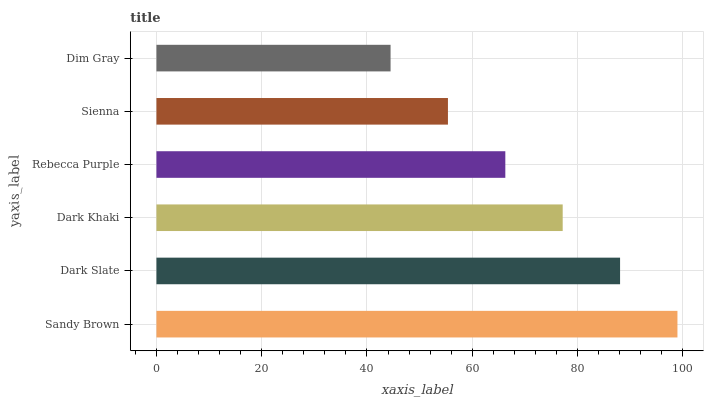Is Dim Gray the minimum?
Answer yes or no. Yes. Is Sandy Brown the maximum?
Answer yes or no. Yes. Is Dark Slate the minimum?
Answer yes or no. No. Is Dark Slate the maximum?
Answer yes or no. No. Is Sandy Brown greater than Dark Slate?
Answer yes or no. Yes. Is Dark Slate less than Sandy Brown?
Answer yes or no. Yes. Is Dark Slate greater than Sandy Brown?
Answer yes or no. No. Is Sandy Brown less than Dark Slate?
Answer yes or no. No. Is Dark Khaki the high median?
Answer yes or no. Yes. Is Rebecca Purple the low median?
Answer yes or no. Yes. Is Dark Slate the high median?
Answer yes or no. No. Is Dim Gray the low median?
Answer yes or no. No. 